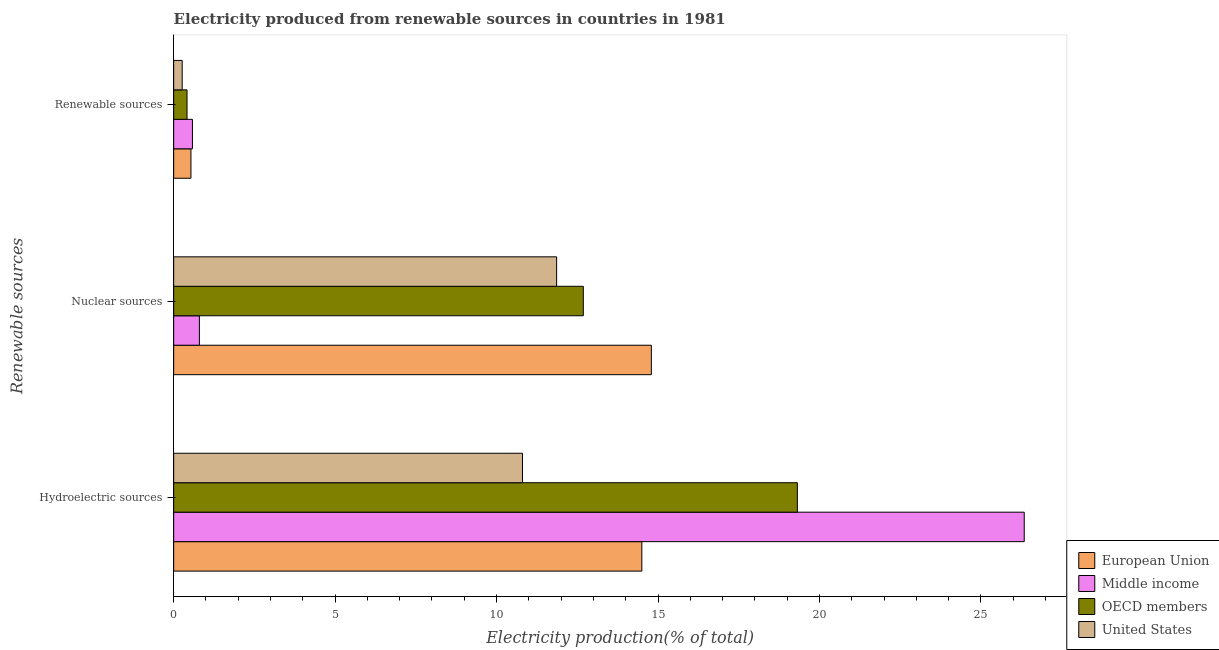Are the number of bars on each tick of the Y-axis equal?
Offer a very short reply. Yes. How many bars are there on the 2nd tick from the bottom?
Offer a terse response. 4. What is the label of the 2nd group of bars from the top?
Provide a short and direct response. Nuclear sources. What is the percentage of electricity produced by hydroelectric sources in OECD members?
Make the answer very short. 19.32. Across all countries, what is the maximum percentage of electricity produced by renewable sources?
Make the answer very short. 0.58. Across all countries, what is the minimum percentage of electricity produced by nuclear sources?
Offer a terse response. 0.8. What is the total percentage of electricity produced by renewable sources in the graph?
Your answer should be very brief. 1.79. What is the difference between the percentage of electricity produced by renewable sources in European Union and that in OECD members?
Keep it short and to the point. 0.12. What is the difference between the percentage of electricity produced by nuclear sources in United States and the percentage of electricity produced by hydroelectric sources in Middle income?
Make the answer very short. -14.48. What is the average percentage of electricity produced by hydroelectric sources per country?
Give a very brief answer. 17.74. What is the difference between the percentage of electricity produced by hydroelectric sources and percentage of electricity produced by renewable sources in United States?
Provide a short and direct response. 10.54. In how many countries, is the percentage of electricity produced by renewable sources greater than 23 %?
Your answer should be very brief. 0. What is the ratio of the percentage of electricity produced by renewable sources in Middle income to that in OECD members?
Offer a very short reply. 1.4. What is the difference between the highest and the second highest percentage of electricity produced by hydroelectric sources?
Provide a succinct answer. 7.03. What is the difference between the highest and the lowest percentage of electricity produced by hydroelectric sources?
Make the answer very short. 15.54. Is the sum of the percentage of electricity produced by hydroelectric sources in European Union and Middle income greater than the maximum percentage of electricity produced by renewable sources across all countries?
Offer a terse response. Yes. What does the 4th bar from the top in Nuclear sources represents?
Your answer should be compact. European Union. Is it the case that in every country, the sum of the percentage of electricity produced by hydroelectric sources and percentage of electricity produced by nuclear sources is greater than the percentage of electricity produced by renewable sources?
Your response must be concise. Yes. How many bars are there?
Provide a short and direct response. 12. Are all the bars in the graph horizontal?
Your response must be concise. Yes. How many countries are there in the graph?
Your response must be concise. 4. What is the difference between two consecutive major ticks on the X-axis?
Keep it short and to the point. 5. Where does the legend appear in the graph?
Ensure brevity in your answer.  Bottom right. What is the title of the graph?
Your answer should be very brief. Electricity produced from renewable sources in countries in 1981. What is the label or title of the X-axis?
Provide a succinct answer. Electricity production(% of total). What is the label or title of the Y-axis?
Ensure brevity in your answer.  Renewable sources. What is the Electricity production(% of total) of European Union in Hydroelectric sources?
Offer a very short reply. 14.5. What is the Electricity production(% of total) in Middle income in Hydroelectric sources?
Offer a very short reply. 26.34. What is the Electricity production(% of total) in OECD members in Hydroelectric sources?
Your answer should be compact. 19.32. What is the Electricity production(% of total) of United States in Hydroelectric sources?
Provide a short and direct response. 10.8. What is the Electricity production(% of total) in European Union in Nuclear sources?
Give a very brief answer. 14.79. What is the Electricity production(% of total) of Middle income in Nuclear sources?
Your answer should be compact. 0.8. What is the Electricity production(% of total) in OECD members in Nuclear sources?
Your response must be concise. 12.69. What is the Electricity production(% of total) in United States in Nuclear sources?
Your answer should be very brief. 11.86. What is the Electricity production(% of total) in European Union in Renewable sources?
Give a very brief answer. 0.53. What is the Electricity production(% of total) of Middle income in Renewable sources?
Provide a short and direct response. 0.58. What is the Electricity production(% of total) in OECD members in Renewable sources?
Offer a very short reply. 0.41. What is the Electricity production(% of total) in United States in Renewable sources?
Your answer should be compact. 0.26. Across all Renewable sources, what is the maximum Electricity production(% of total) in European Union?
Give a very brief answer. 14.79. Across all Renewable sources, what is the maximum Electricity production(% of total) of Middle income?
Provide a succinct answer. 26.34. Across all Renewable sources, what is the maximum Electricity production(% of total) of OECD members?
Your response must be concise. 19.32. Across all Renewable sources, what is the maximum Electricity production(% of total) in United States?
Give a very brief answer. 11.86. Across all Renewable sources, what is the minimum Electricity production(% of total) in European Union?
Provide a succinct answer. 0.53. Across all Renewable sources, what is the minimum Electricity production(% of total) of Middle income?
Your answer should be compact. 0.58. Across all Renewable sources, what is the minimum Electricity production(% of total) of OECD members?
Offer a terse response. 0.41. Across all Renewable sources, what is the minimum Electricity production(% of total) in United States?
Offer a very short reply. 0.26. What is the total Electricity production(% of total) in European Union in the graph?
Offer a very short reply. 29.83. What is the total Electricity production(% of total) in Middle income in the graph?
Make the answer very short. 27.72. What is the total Electricity production(% of total) of OECD members in the graph?
Your answer should be very brief. 32.42. What is the total Electricity production(% of total) of United States in the graph?
Offer a very short reply. 22.93. What is the difference between the Electricity production(% of total) of European Union in Hydroelectric sources and that in Nuclear sources?
Keep it short and to the point. -0.29. What is the difference between the Electricity production(% of total) in Middle income in Hydroelectric sources and that in Nuclear sources?
Ensure brevity in your answer.  25.55. What is the difference between the Electricity production(% of total) of OECD members in Hydroelectric sources and that in Nuclear sources?
Your answer should be compact. 6.63. What is the difference between the Electricity production(% of total) of United States in Hydroelectric sources and that in Nuclear sources?
Provide a succinct answer. -1.06. What is the difference between the Electricity production(% of total) of European Union in Hydroelectric sources and that in Renewable sources?
Offer a very short reply. 13.96. What is the difference between the Electricity production(% of total) of Middle income in Hydroelectric sources and that in Renewable sources?
Your answer should be very brief. 25.76. What is the difference between the Electricity production(% of total) in OECD members in Hydroelectric sources and that in Renewable sources?
Your answer should be very brief. 18.9. What is the difference between the Electricity production(% of total) in United States in Hydroelectric sources and that in Renewable sources?
Your answer should be compact. 10.54. What is the difference between the Electricity production(% of total) of European Union in Nuclear sources and that in Renewable sources?
Keep it short and to the point. 14.26. What is the difference between the Electricity production(% of total) of Middle income in Nuclear sources and that in Renewable sources?
Ensure brevity in your answer.  0.22. What is the difference between the Electricity production(% of total) of OECD members in Nuclear sources and that in Renewable sources?
Make the answer very short. 12.27. What is the difference between the Electricity production(% of total) in United States in Nuclear sources and that in Renewable sources?
Provide a succinct answer. 11.6. What is the difference between the Electricity production(% of total) of European Union in Hydroelectric sources and the Electricity production(% of total) of Middle income in Nuclear sources?
Provide a succinct answer. 13.7. What is the difference between the Electricity production(% of total) in European Union in Hydroelectric sources and the Electricity production(% of total) in OECD members in Nuclear sources?
Your answer should be very brief. 1.81. What is the difference between the Electricity production(% of total) in European Union in Hydroelectric sources and the Electricity production(% of total) in United States in Nuclear sources?
Make the answer very short. 2.64. What is the difference between the Electricity production(% of total) in Middle income in Hydroelectric sources and the Electricity production(% of total) in OECD members in Nuclear sources?
Keep it short and to the point. 13.66. What is the difference between the Electricity production(% of total) in Middle income in Hydroelectric sources and the Electricity production(% of total) in United States in Nuclear sources?
Your answer should be very brief. 14.48. What is the difference between the Electricity production(% of total) in OECD members in Hydroelectric sources and the Electricity production(% of total) in United States in Nuclear sources?
Your answer should be compact. 7.46. What is the difference between the Electricity production(% of total) in European Union in Hydroelectric sources and the Electricity production(% of total) in Middle income in Renewable sources?
Provide a succinct answer. 13.92. What is the difference between the Electricity production(% of total) of European Union in Hydroelectric sources and the Electricity production(% of total) of OECD members in Renewable sources?
Keep it short and to the point. 14.09. What is the difference between the Electricity production(% of total) of European Union in Hydroelectric sources and the Electricity production(% of total) of United States in Renewable sources?
Your answer should be compact. 14.24. What is the difference between the Electricity production(% of total) of Middle income in Hydroelectric sources and the Electricity production(% of total) of OECD members in Renewable sources?
Your response must be concise. 25.93. What is the difference between the Electricity production(% of total) in Middle income in Hydroelectric sources and the Electricity production(% of total) in United States in Renewable sources?
Ensure brevity in your answer.  26.08. What is the difference between the Electricity production(% of total) of OECD members in Hydroelectric sources and the Electricity production(% of total) of United States in Renewable sources?
Keep it short and to the point. 19.05. What is the difference between the Electricity production(% of total) of European Union in Nuclear sources and the Electricity production(% of total) of Middle income in Renewable sources?
Your answer should be compact. 14.21. What is the difference between the Electricity production(% of total) in European Union in Nuclear sources and the Electricity production(% of total) in OECD members in Renewable sources?
Offer a very short reply. 14.38. What is the difference between the Electricity production(% of total) of European Union in Nuclear sources and the Electricity production(% of total) of United States in Renewable sources?
Provide a short and direct response. 14.53. What is the difference between the Electricity production(% of total) of Middle income in Nuclear sources and the Electricity production(% of total) of OECD members in Renewable sources?
Ensure brevity in your answer.  0.38. What is the difference between the Electricity production(% of total) of Middle income in Nuclear sources and the Electricity production(% of total) of United States in Renewable sources?
Your response must be concise. 0.53. What is the difference between the Electricity production(% of total) in OECD members in Nuclear sources and the Electricity production(% of total) in United States in Renewable sources?
Give a very brief answer. 12.42. What is the average Electricity production(% of total) in European Union per Renewable sources?
Make the answer very short. 9.94. What is the average Electricity production(% of total) of Middle income per Renewable sources?
Give a very brief answer. 9.24. What is the average Electricity production(% of total) of OECD members per Renewable sources?
Keep it short and to the point. 10.81. What is the average Electricity production(% of total) of United States per Renewable sources?
Give a very brief answer. 7.64. What is the difference between the Electricity production(% of total) in European Union and Electricity production(% of total) in Middle income in Hydroelectric sources?
Your response must be concise. -11.84. What is the difference between the Electricity production(% of total) in European Union and Electricity production(% of total) in OECD members in Hydroelectric sources?
Your answer should be very brief. -4.82. What is the difference between the Electricity production(% of total) in European Union and Electricity production(% of total) in United States in Hydroelectric sources?
Your response must be concise. 3.7. What is the difference between the Electricity production(% of total) of Middle income and Electricity production(% of total) of OECD members in Hydroelectric sources?
Give a very brief answer. 7.03. What is the difference between the Electricity production(% of total) of Middle income and Electricity production(% of total) of United States in Hydroelectric sources?
Your answer should be compact. 15.54. What is the difference between the Electricity production(% of total) of OECD members and Electricity production(% of total) of United States in Hydroelectric sources?
Your answer should be very brief. 8.51. What is the difference between the Electricity production(% of total) of European Union and Electricity production(% of total) of Middle income in Nuclear sources?
Your answer should be very brief. 14. What is the difference between the Electricity production(% of total) in European Union and Electricity production(% of total) in OECD members in Nuclear sources?
Provide a short and direct response. 2.11. What is the difference between the Electricity production(% of total) of European Union and Electricity production(% of total) of United States in Nuclear sources?
Ensure brevity in your answer.  2.93. What is the difference between the Electricity production(% of total) in Middle income and Electricity production(% of total) in OECD members in Nuclear sources?
Your answer should be compact. -11.89. What is the difference between the Electricity production(% of total) of Middle income and Electricity production(% of total) of United States in Nuclear sources?
Keep it short and to the point. -11.06. What is the difference between the Electricity production(% of total) of OECD members and Electricity production(% of total) of United States in Nuclear sources?
Offer a terse response. 0.83. What is the difference between the Electricity production(% of total) of European Union and Electricity production(% of total) of Middle income in Renewable sources?
Keep it short and to the point. -0.05. What is the difference between the Electricity production(% of total) in European Union and Electricity production(% of total) in OECD members in Renewable sources?
Your answer should be compact. 0.12. What is the difference between the Electricity production(% of total) in European Union and Electricity production(% of total) in United States in Renewable sources?
Keep it short and to the point. 0.27. What is the difference between the Electricity production(% of total) in Middle income and Electricity production(% of total) in OECD members in Renewable sources?
Provide a short and direct response. 0.17. What is the difference between the Electricity production(% of total) in Middle income and Electricity production(% of total) in United States in Renewable sources?
Your response must be concise. 0.32. What is the difference between the Electricity production(% of total) of OECD members and Electricity production(% of total) of United States in Renewable sources?
Offer a terse response. 0.15. What is the ratio of the Electricity production(% of total) of European Union in Hydroelectric sources to that in Nuclear sources?
Your answer should be very brief. 0.98. What is the ratio of the Electricity production(% of total) in Middle income in Hydroelectric sources to that in Nuclear sources?
Ensure brevity in your answer.  33.06. What is the ratio of the Electricity production(% of total) in OECD members in Hydroelectric sources to that in Nuclear sources?
Make the answer very short. 1.52. What is the ratio of the Electricity production(% of total) of United States in Hydroelectric sources to that in Nuclear sources?
Offer a terse response. 0.91. What is the ratio of the Electricity production(% of total) of European Union in Hydroelectric sources to that in Renewable sources?
Your answer should be compact. 27.13. What is the ratio of the Electricity production(% of total) of Middle income in Hydroelectric sources to that in Renewable sources?
Ensure brevity in your answer.  45.32. What is the ratio of the Electricity production(% of total) of OECD members in Hydroelectric sources to that in Renewable sources?
Keep it short and to the point. 46.68. What is the ratio of the Electricity production(% of total) of United States in Hydroelectric sources to that in Renewable sources?
Make the answer very short. 41. What is the ratio of the Electricity production(% of total) of European Union in Nuclear sources to that in Renewable sources?
Offer a terse response. 27.68. What is the ratio of the Electricity production(% of total) of Middle income in Nuclear sources to that in Renewable sources?
Provide a short and direct response. 1.37. What is the ratio of the Electricity production(% of total) of OECD members in Nuclear sources to that in Renewable sources?
Give a very brief answer. 30.66. What is the ratio of the Electricity production(% of total) in United States in Nuclear sources to that in Renewable sources?
Provide a short and direct response. 45.01. What is the difference between the highest and the second highest Electricity production(% of total) of European Union?
Keep it short and to the point. 0.29. What is the difference between the highest and the second highest Electricity production(% of total) in Middle income?
Offer a very short reply. 25.55. What is the difference between the highest and the second highest Electricity production(% of total) in OECD members?
Keep it short and to the point. 6.63. What is the difference between the highest and the second highest Electricity production(% of total) of United States?
Your response must be concise. 1.06. What is the difference between the highest and the lowest Electricity production(% of total) of European Union?
Offer a terse response. 14.26. What is the difference between the highest and the lowest Electricity production(% of total) of Middle income?
Give a very brief answer. 25.76. What is the difference between the highest and the lowest Electricity production(% of total) in OECD members?
Give a very brief answer. 18.9. What is the difference between the highest and the lowest Electricity production(% of total) of United States?
Your answer should be compact. 11.6. 